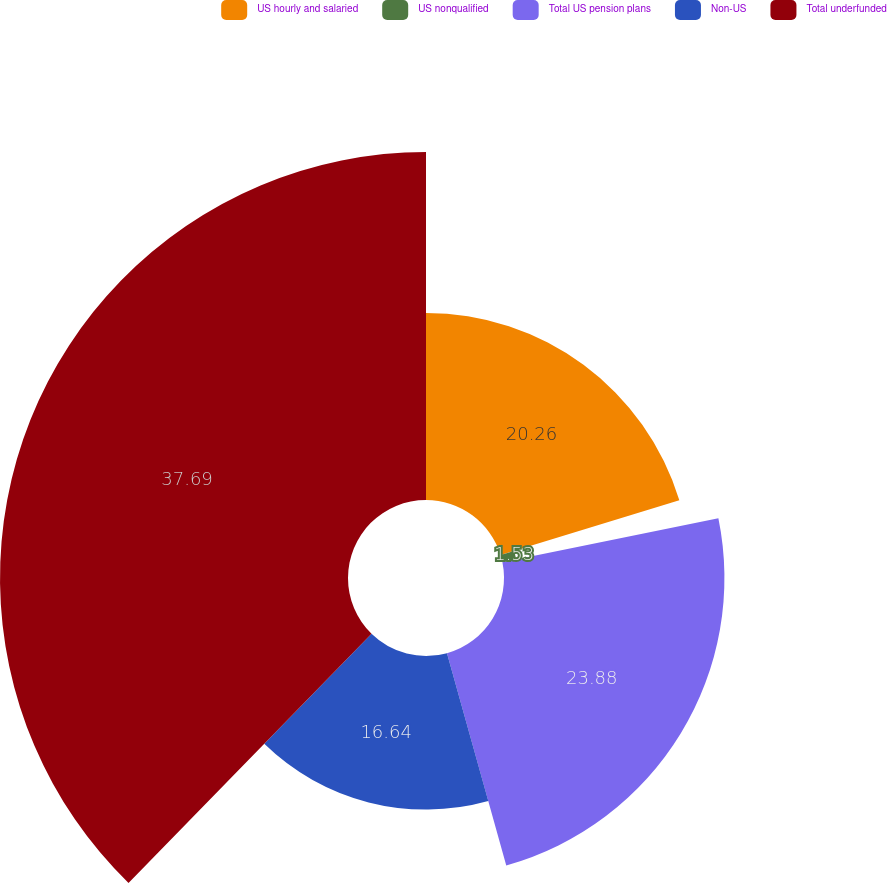<chart> <loc_0><loc_0><loc_500><loc_500><pie_chart><fcel>US hourly and salaried<fcel>US nonqualified<fcel>Total US pension plans<fcel>Non-US<fcel>Total underfunded<nl><fcel>20.26%<fcel>1.53%<fcel>23.88%<fcel>16.64%<fcel>37.7%<nl></chart> 